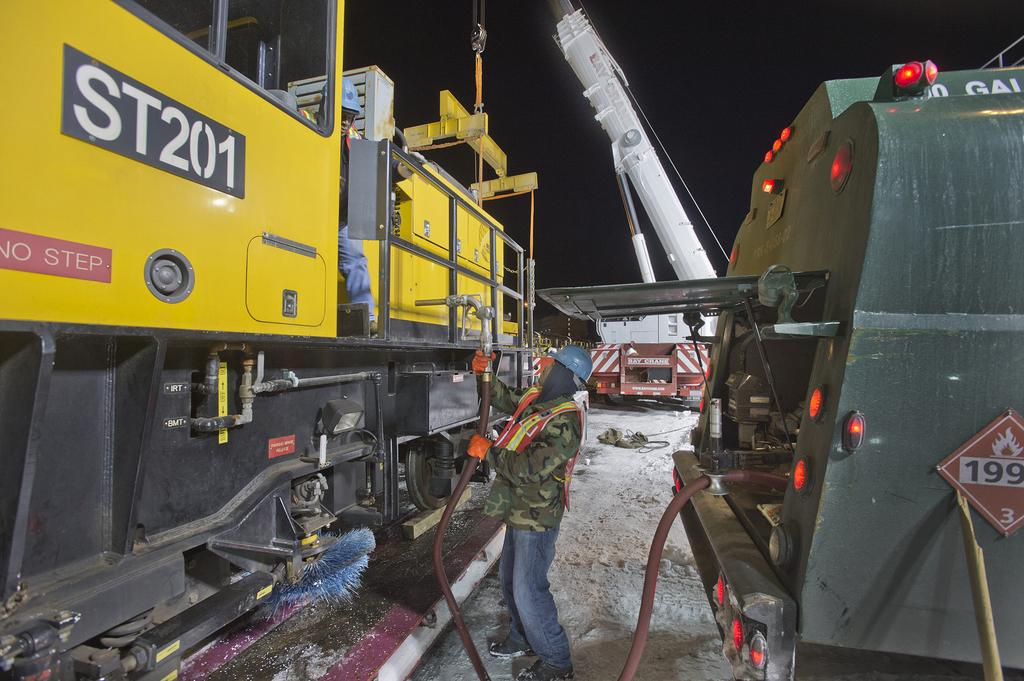<image>
Offer a succinct explanation of the picture presented. A large piece of industrial equipment with the number ST201 on it 